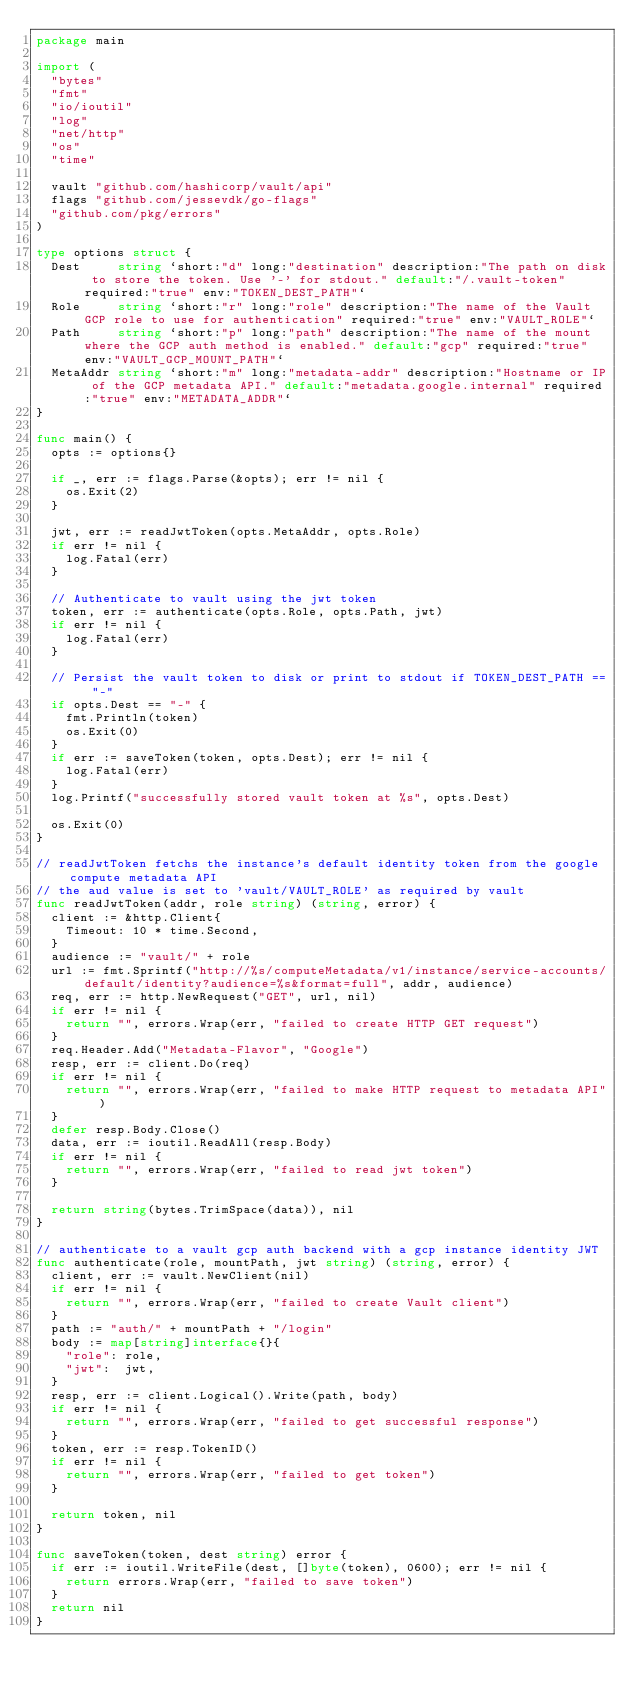Convert code to text. <code><loc_0><loc_0><loc_500><loc_500><_Go_>package main

import (
	"bytes"
	"fmt"
	"io/ioutil"
	"log"
	"net/http"
	"os"
	"time"

	vault "github.com/hashicorp/vault/api"
	flags "github.com/jessevdk/go-flags"
	"github.com/pkg/errors"
)

type options struct {
	Dest     string `short:"d" long:"destination" description:"The path on disk to store the token. Use '-' for stdout." default:"/.vault-token" required:"true" env:"TOKEN_DEST_PATH"`
	Role     string `short:"r" long:"role" description:"The name of the Vault GCP role to use for authentication" required:"true" env:"VAULT_ROLE"`
	Path     string `short:"p" long:"path" description:"The name of the mount where the GCP auth method is enabled." default:"gcp" required:"true" env:"VAULT_GCP_MOUNT_PATH"`
	MetaAddr string `short:"m" long:"metadata-addr" description:"Hostname or IP of the GCP metadata API." default:"metadata.google.internal" required:"true" env:"METADATA_ADDR"`
}

func main() {
	opts := options{}

	if _, err := flags.Parse(&opts); err != nil {
		os.Exit(2)
	}

	jwt, err := readJwtToken(opts.MetaAddr, opts.Role)
	if err != nil {
		log.Fatal(err)
	}

	// Authenticate to vault using the jwt token
	token, err := authenticate(opts.Role, opts.Path, jwt)
	if err != nil {
		log.Fatal(err)
	}

	// Persist the vault token to disk or print to stdout if TOKEN_DEST_PATH == "-"
	if opts.Dest == "-" {
		fmt.Println(token)
		os.Exit(0)
	}
	if err := saveToken(token, opts.Dest); err != nil {
		log.Fatal(err)
	}
	log.Printf("successfully stored vault token at %s", opts.Dest)

	os.Exit(0)
}

// readJwtToken fetchs the instance's default identity token from the google compute metadata API
// the aud value is set to 'vault/VAULT_ROLE' as required by vault
func readJwtToken(addr, role string) (string, error) {
	client := &http.Client{
		Timeout: 10 * time.Second,
	}
	audience := "vault/" + role
	url := fmt.Sprintf("http://%s/computeMetadata/v1/instance/service-accounts/default/identity?audience=%s&format=full", addr, audience)
	req, err := http.NewRequest("GET", url, nil)
	if err != nil {
		return "", errors.Wrap(err, "failed to create HTTP GET request")
	}
	req.Header.Add("Metadata-Flavor", "Google")
	resp, err := client.Do(req)
	if err != nil {
		return "", errors.Wrap(err, "failed to make HTTP request to metadata API")
	}
	defer resp.Body.Close()
	data, err := ioutil.ReadAll(resp.Body)
	if err != nil {
		return "", errors.Wrap(err, "failed to read jwt token")
	}

	return string(bytes.TrimSpace(data)), nil
}

// authenticate to a vault gcp auth backend with a gcp instance identity JWT
func authenticate(role, mountPath, jwt string) (string, error) {
	client, err := vault.NewClient(nil)
	if err != nil {
		return "", errors.Wrap(err, "failed to create Vault client")
	}
	path := "auth/" + mountPath + "/login"
	body := map[string]interface{}{
		"role": role,
		"jwt":  jwt,
	}
	resp, err := client.Logical().Write(path, body)
	if err != nil {
		return "", errors.Wrap(err, "failed to get successful response")
	}
	token, err := resp.TokenID()
	if err != nil {
		return "", errors.Wrap(err, "failed to get token")
	}

	return token, nil
}

func saveToken(token, dest string) error {
	if err := ioutil.WriteFile(dest, []byte(token), 0600); err != nil {
		return errors.Wrap(err, "failed to save token")
	}
	return nil
}
</code> 